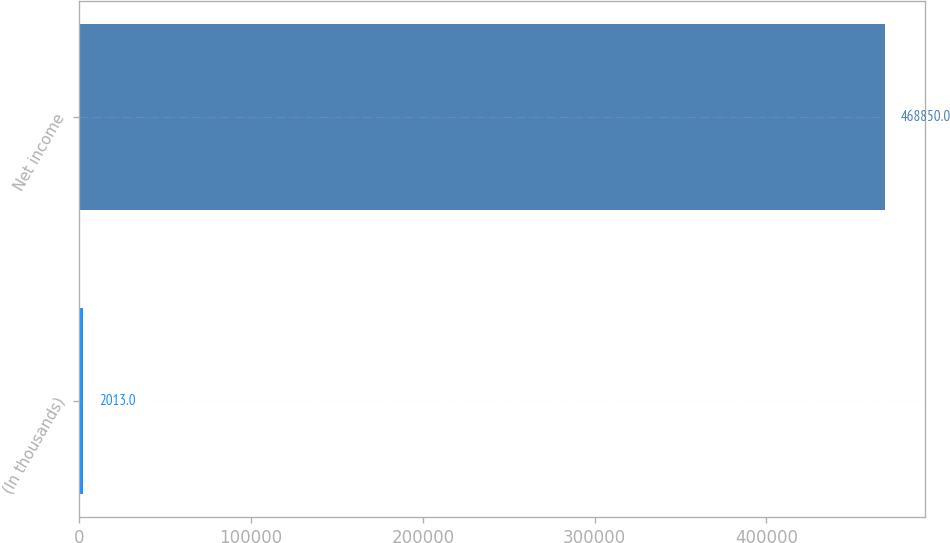Convert chart. <chart><loc_0><loc_0><loc_500><loc_500><bar_chart><fcel>(In thousands)<fcel>Net income<nl><fcel>2013<fcel>468850<nl></chart> 